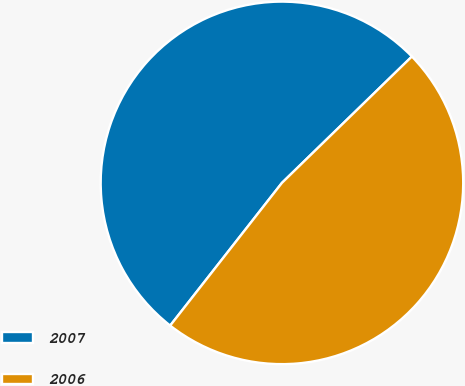Convert chart. <chart><loc_0><loc_0><loc_500><loc_500><pie_chart><fcel>2007<fcel>2006<nl><fcel>52.15%<fcel>47.85%<nl></chart> 